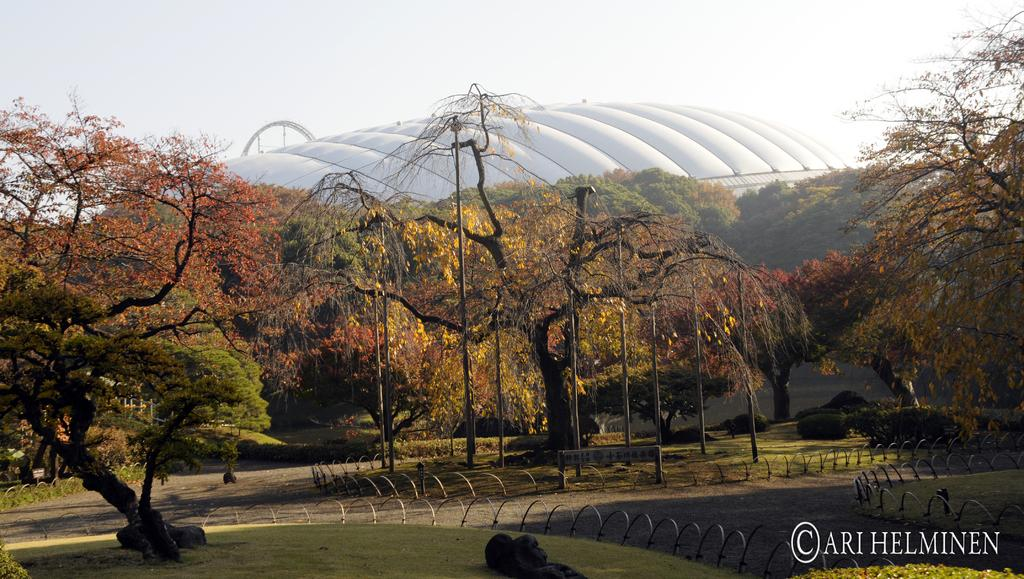What type of vegetation can be seen in the image? There are trees, plants, and grass visible in the image. What structures are present in the image? There are poles in the image. What can be seen in the background of the image? There is a building in the background of the image. What is visible at the top of the image? The sky is visible at the top of the image. Can you see any fish swimming in the grass in the image? There are no fish present in the image, and the grass is not a body of water where fish would swim. Are there any apples growing on the trees in the image? There is no information about the type of trees or their fruit in the image, so it cannot be determined if there are apples growing on them. 